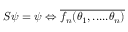<formula> <loc_0><loc_0><loc_500><loc_500>S \psi = \psi \Leftrightarrow \overline { { { f _ { n } ( \theta _ { 1 } , \cdots . \theta _ { n } ) } } }</formula> 